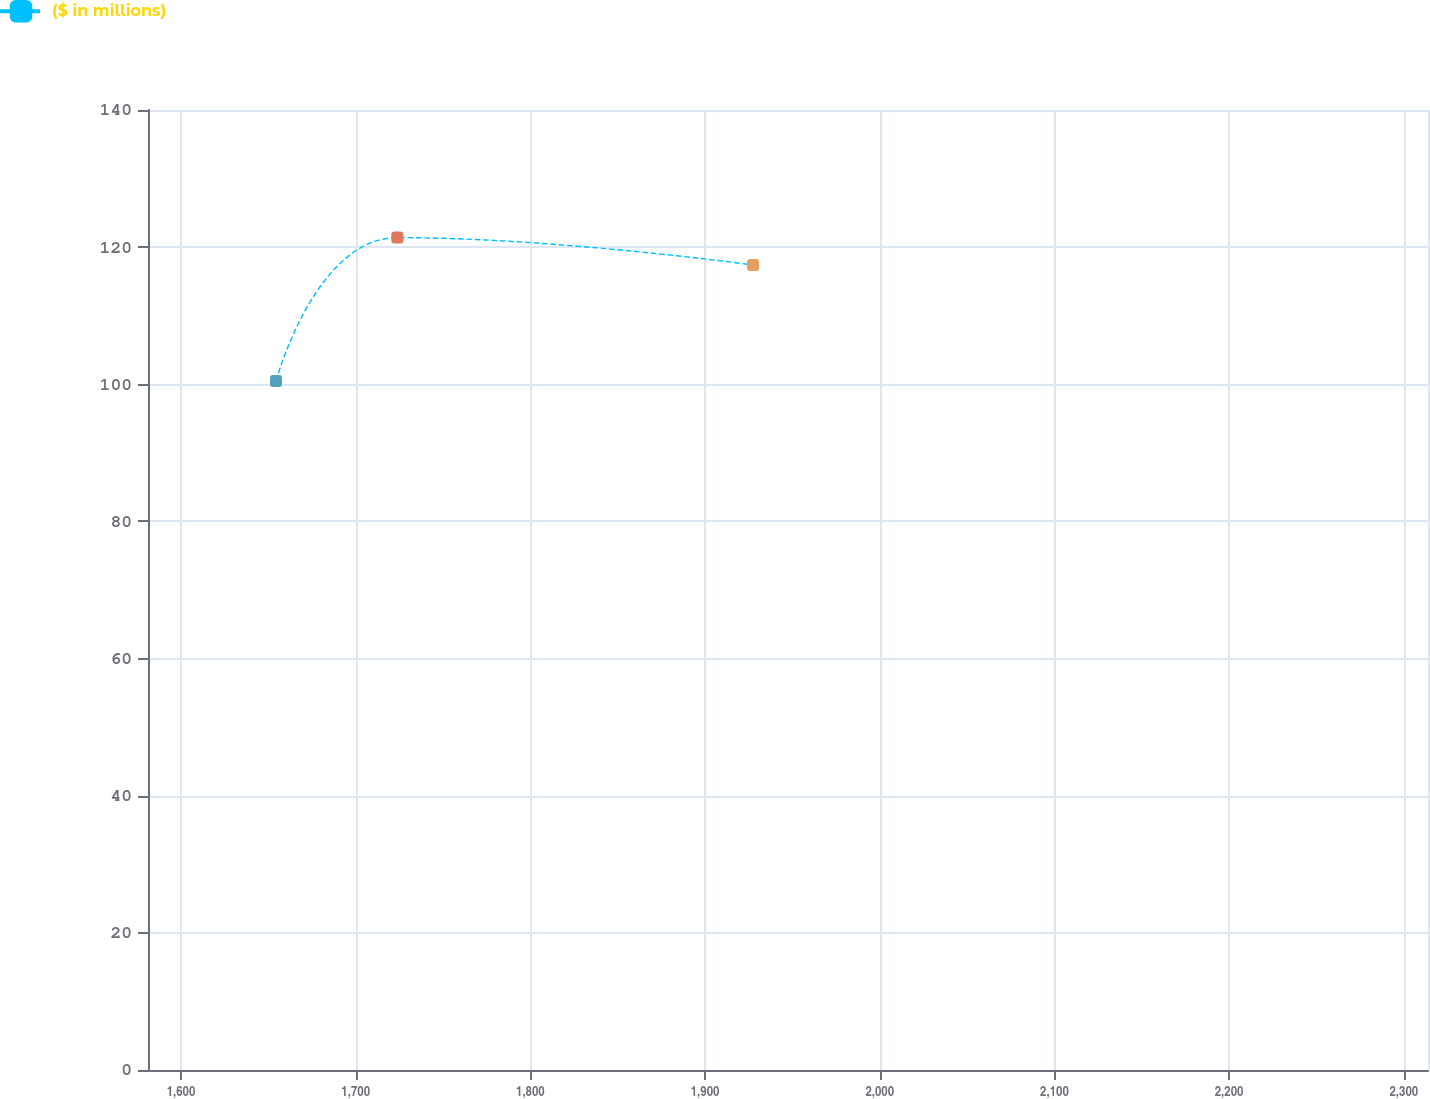Convert chart. <chart><loc_0><loc_0><loc_500><loc_500><line_chart><ecel><fcel>($ in millions)<nl><fcel>1654.37<fcel>100.47<nl><fcel>1723.82<fcel>121.39<nl><fcel>1927.47<fcel>117.4<nl><fcel>2317.69<fcel>114.87<nl><fcel>2387.14<fcel>125.79<nl></chart> 